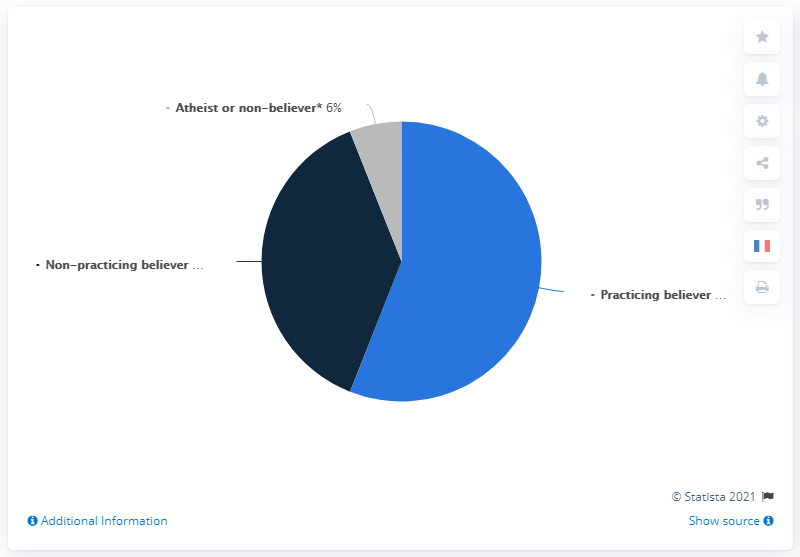Point out several critical features in this image. It can be declared that the share of believers who have the least value is that of atheists or non-believers. The least value and the sum of the other two values are different. 